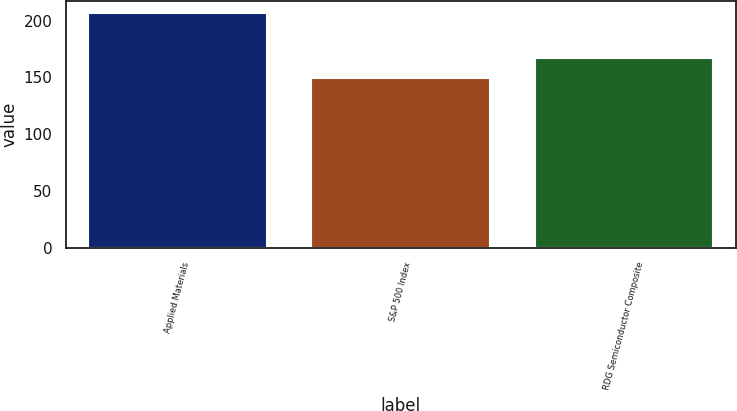Convert chart to OTSL. <chart><loc_0><loc_0><loc_500><loc_500><bar_chart><fcel>Applied Materials<fcel>S&P 500 Index<fcel>RDG Semiconductor Composite<nl><fcel>207.01<fcel>149.14<fcel>167.25<nl></chart> 